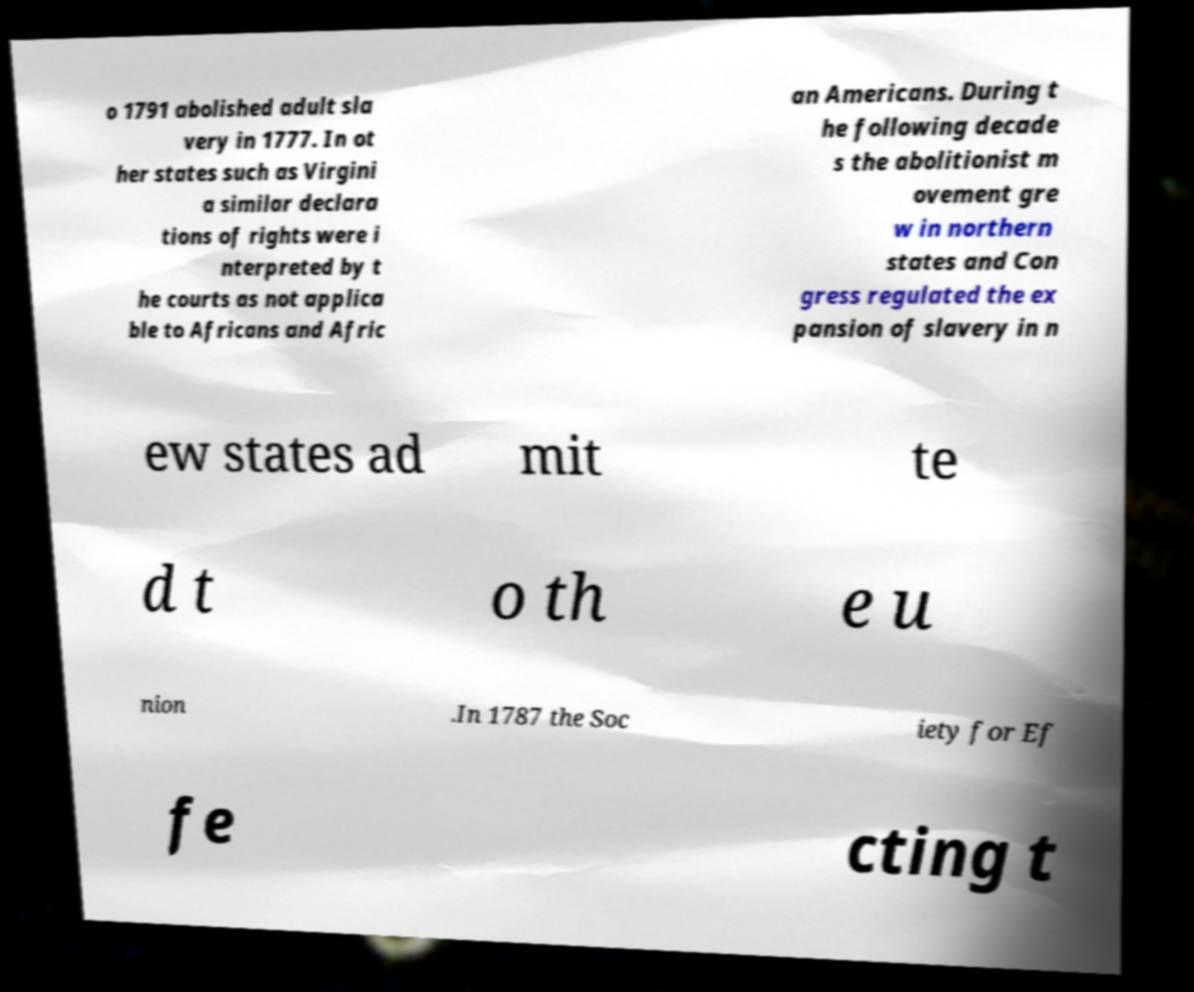Could you extract and type out the text from this image? o 1791 abolished adult sla very in 1777. In ot her states such as Virgini a similar declara tions of rights were i nterpreted by t he courts as not applica ble to Africans and Afric an Americans. During t he following decade s the abolitionist m ovement gre w in northern states and Con gress regulated the ex pansion of slavery in n ew states ad mit te d t o th e u nion .In 1787 the Soc iety for Ef fe cting t 